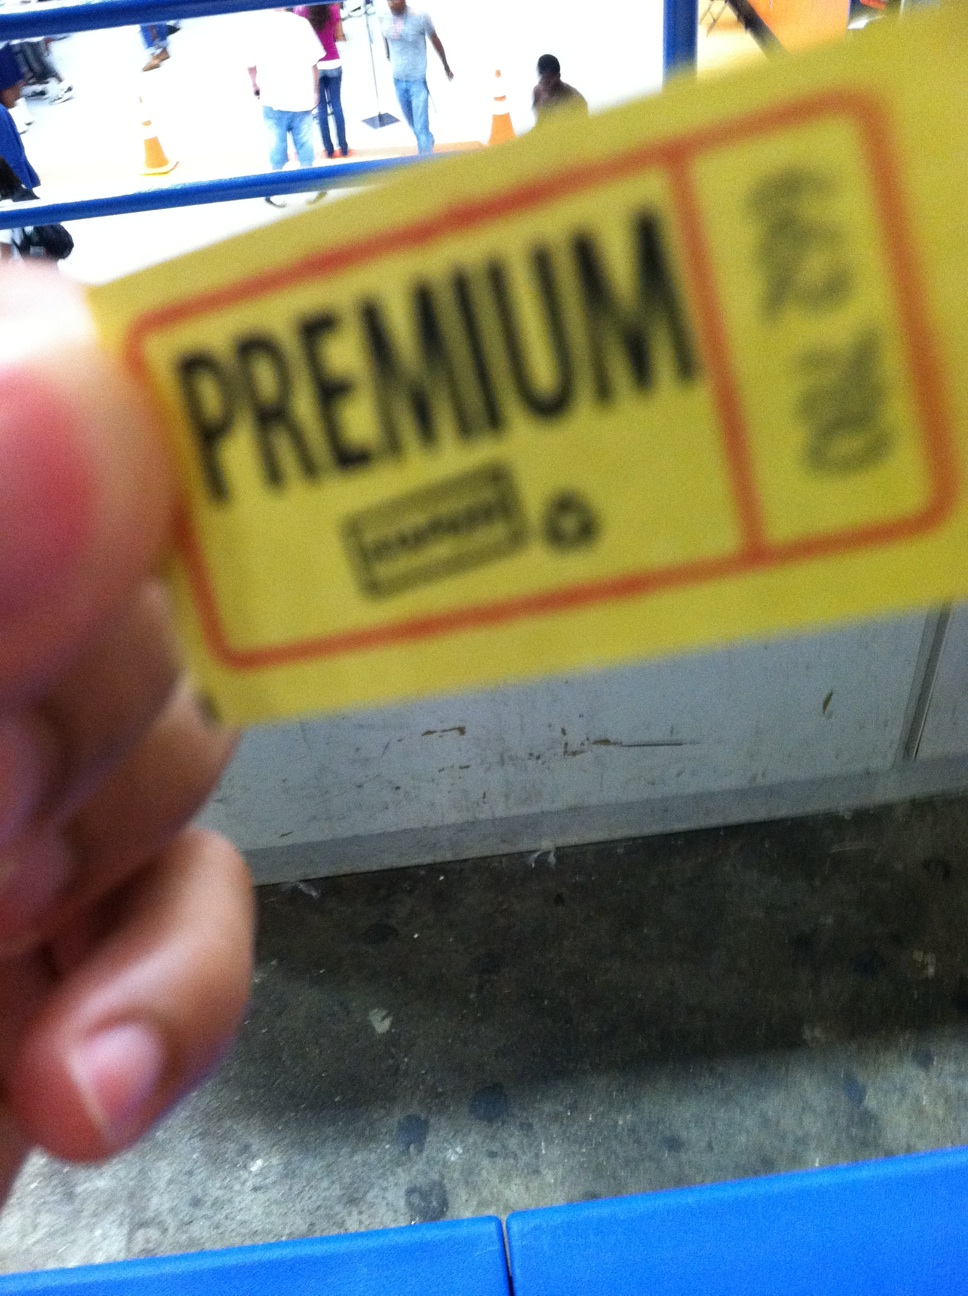What number is this? Unfortunately, it appears that the image does not contain a clear view of any numbers; instead, it shows a blurred and partially obstructed view of a yellow card or ticket with the word 'PREMIUM' visible on it. To provide a precise answer, a clearer image or additional context would be needed. 